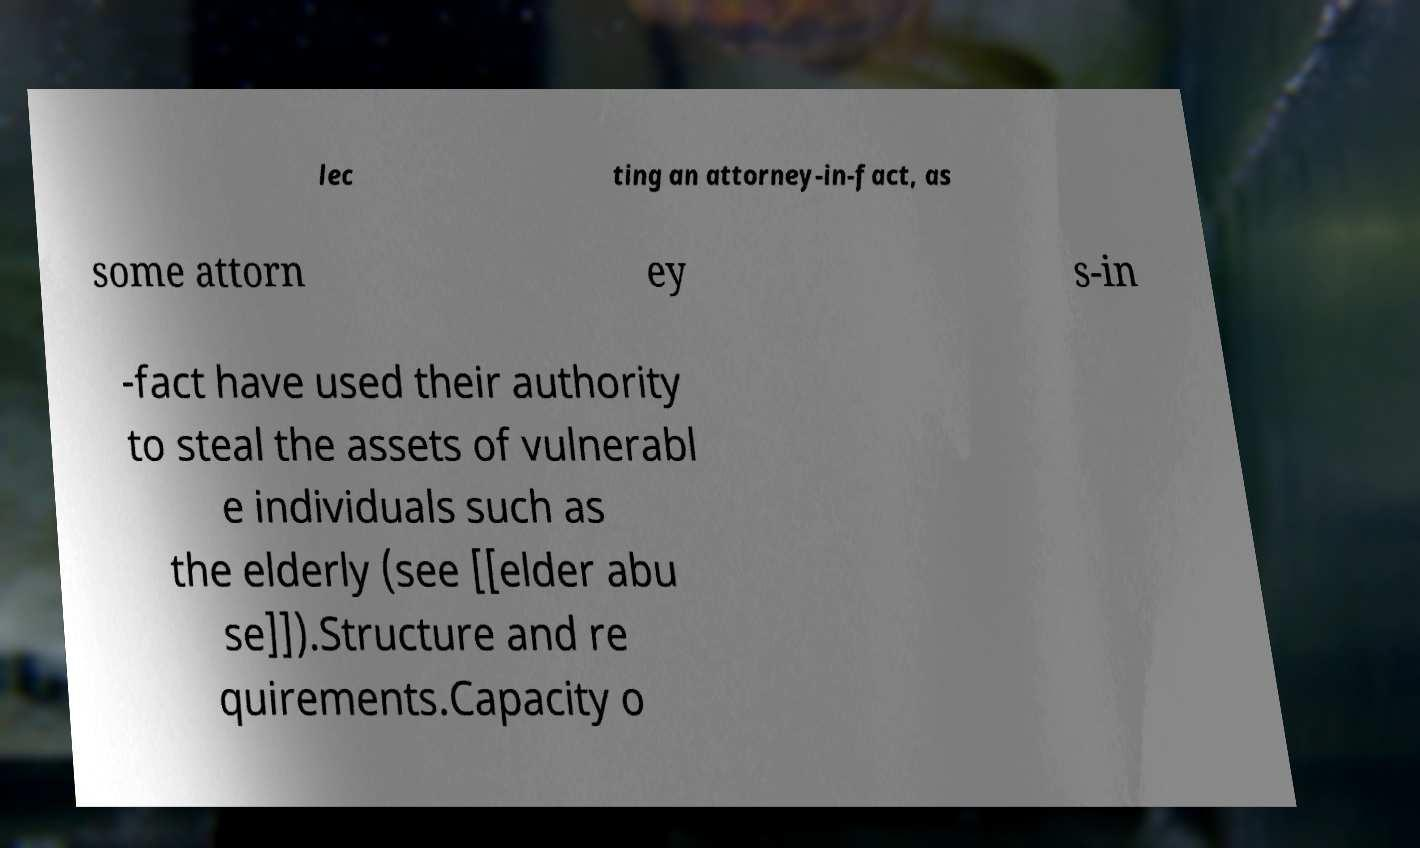Please identify and transcribe the text found in this image. lec ting an attorney-in-fact, as some attorn ey s-in -fact have used their authority to steal the assets of vulnerabl e individuals such as the elderly (see [[elder abu se]]).Structure and re quirements.Capacity o 